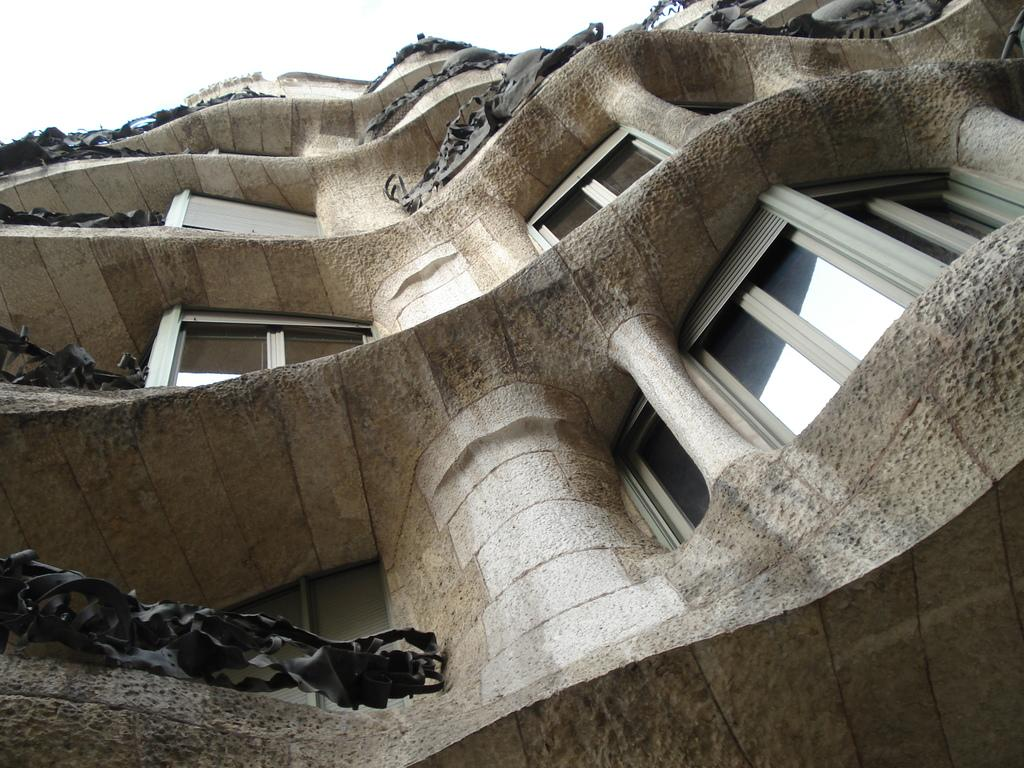What type of structure is present in the image? There is a building in the image. What feature can be seen on the building? There are windows in the building. What objects are visible in the image? Glasses are visible in the image. What can be seen in the background of the image? The sky is visible in the background of the image. What is the governor doing in the image? There is no governor present in the image. What is the chance of finding a stem in the image? There is no stem present in the image, so it is not possible to determine the chance of finding one. 